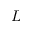Convert formula to latex. <formula><loc_0><loc_0><loc_500><loc_500>L</formula> 